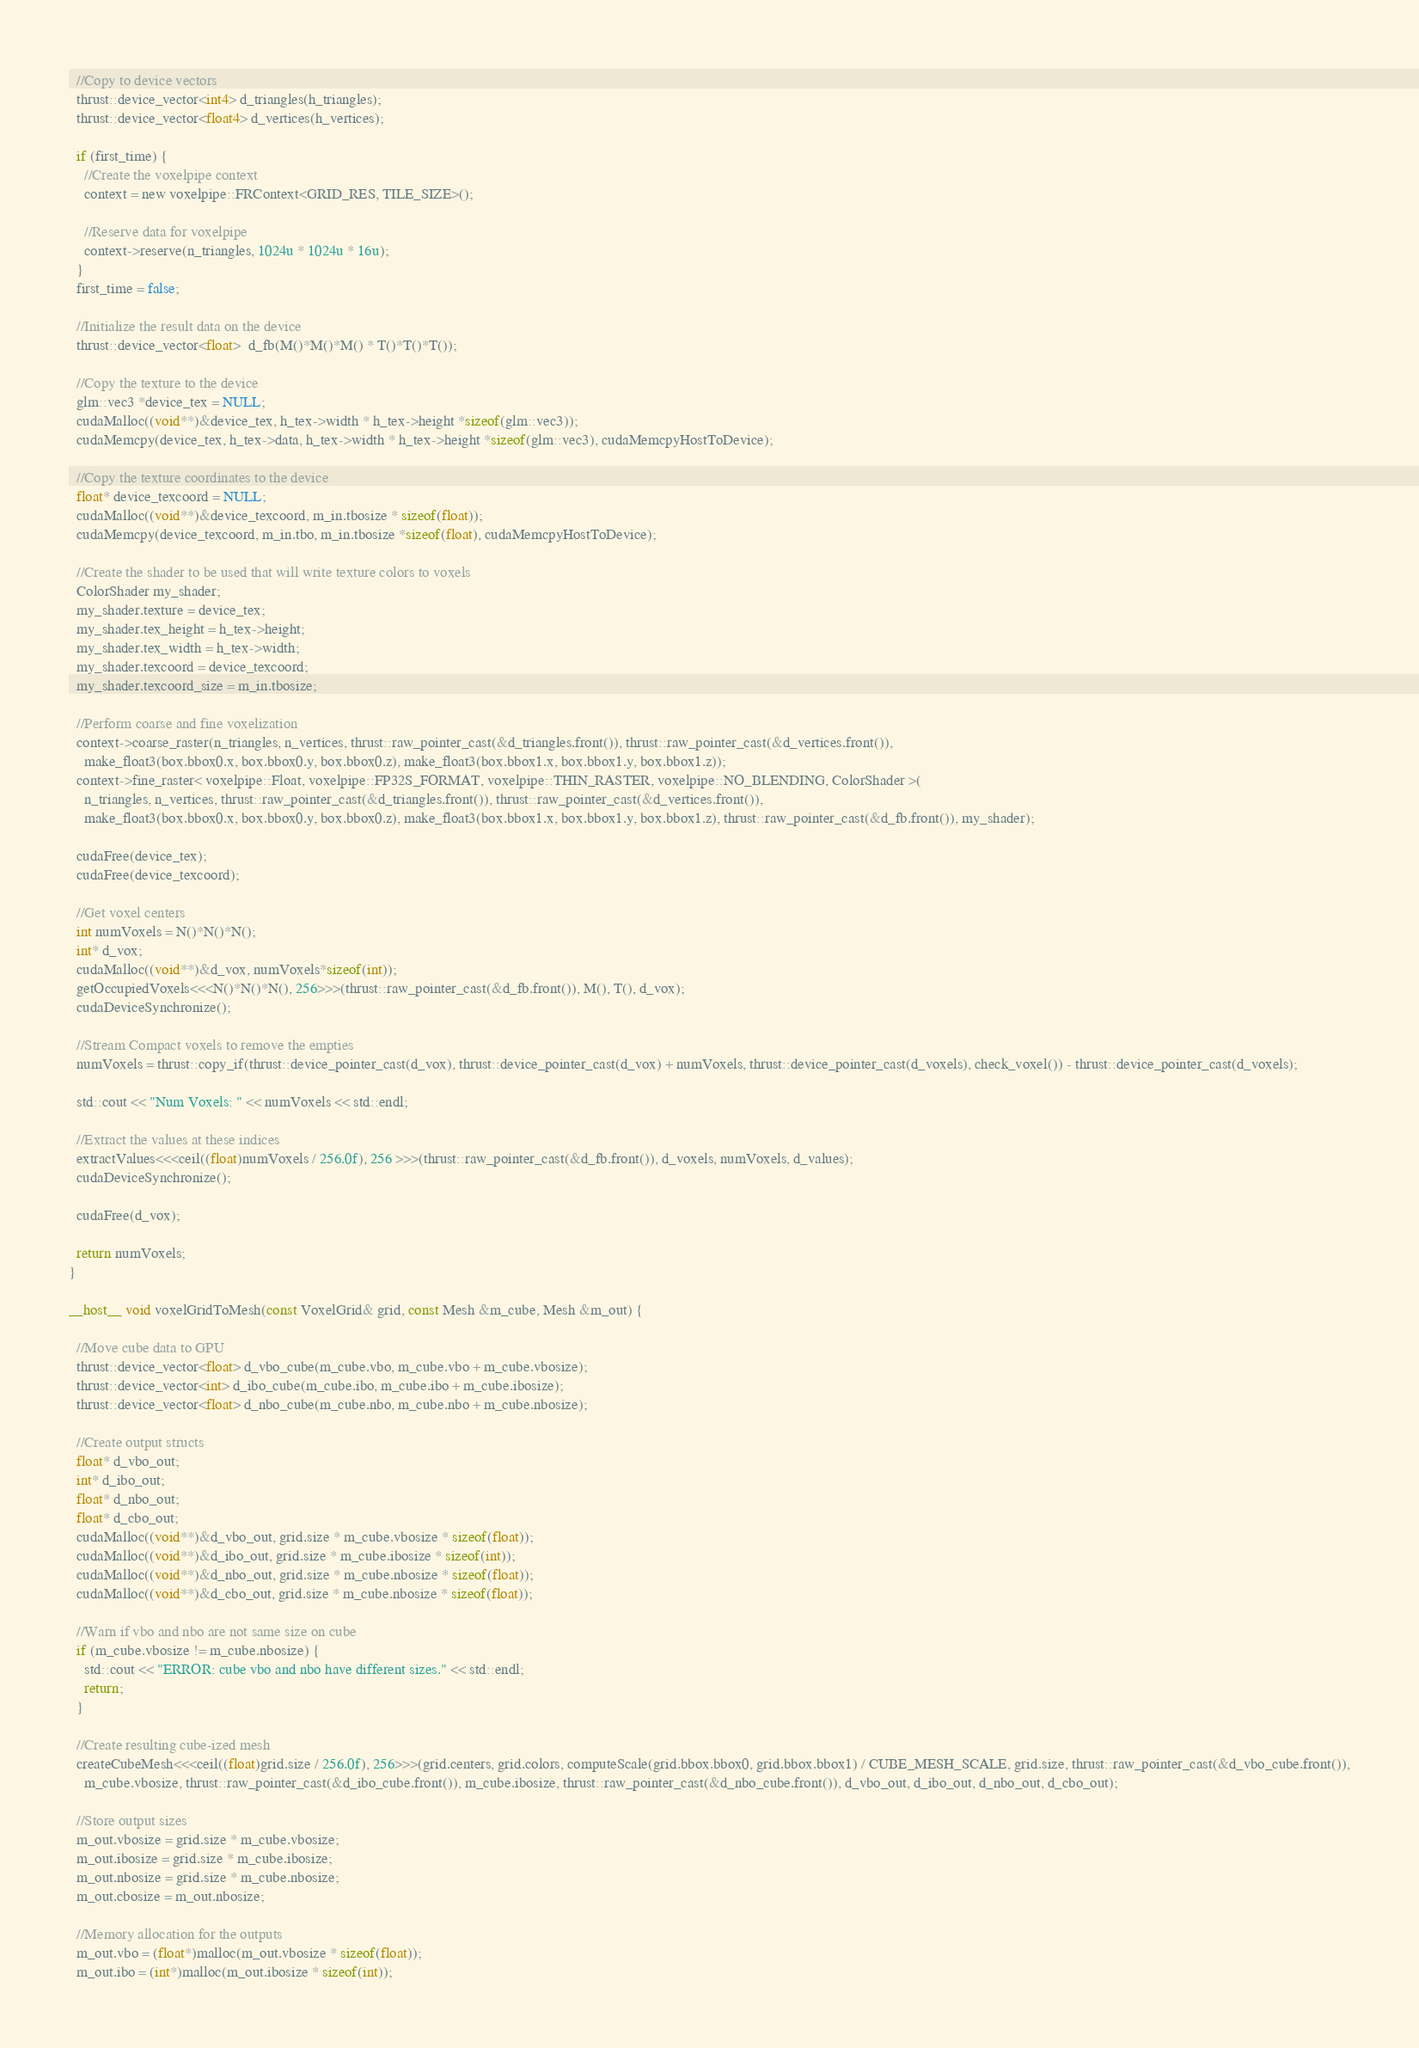Convert code to text. <code><loc_0><loc_0><loc_500><loc_500><_Cuda_>  //Copy to device vectors
  thrust::device_vector<int4> d_triangles(h_triangles);
  thrust::device_vector<float4> d_vertices(h_vertices);

  if (first_time) {
    //Create the voxelpipe context
    context = new voxelpipe::FRContext<GRID_RES, TILE_SIZE>();

    //Reserve data for voxelpipe
    context->reserve(n_triangles, 1024u * 1024u * 16u);
  }
  first_time = false;

  //Initialize the result data on the device
  thrust::device_vector<float>  d_fb(M()*M()*M() * T()*T()*T());

  //Copy the texture to the device
  glm::vec3 *device_tex = NULL;
  cudaMalloc((void**)&device_tex, h_tex->width * h_tex->height *sizeof(glm::vec3));
  cudaMemcpy(device_tex, h_tex->data, h_tex->width * h_tex->height *sizeof(glm::vec3), cudaMemcpyHostToDevice);

  //Copy the texture coordinates to the device
  float* device_texcoord = NULL;
  cudaMalloc((void**)&device_texcoord, m_in.tbosize * sizeof(float));
  cudaMemcpy(device_texcoord, m_in.tbo, m_in.tbosize *sizeof(float), cudaMemcpyHostToDevice);

  //Create the shader to be used that will write texture colors to voxels
  ColorShader my_shader;
  my_shader.texture = device_tex;
  my_shader.tex_height = h_tex->height;
  my_shader.tex_width = h_tex->width;
  my_shader.texcoord = device_texcoord;
  my_shader.texcoord_size = m_in.tbosize;

  //Perform coarse and fine voxelization
  context->coarse_raster(n_triangles, n_vertices, thrust::raw_pointer_cast(&d_triangles.front()), thrust::raw_pointer_cast(&d_vertices.front()), 
    make_float3(box.bbox0.x, box.bbox0.y, box.bbox0.z), make_float3(box.bbox1.x, box.bbox1.y, box.bbox1.z));
  context->fine_raster< voxelpipe::Float, voxelpipe::FP32S_FORMAT, voxelpipe::THIN_RASTER, voxelpipe::NO_BLENDING, ColorShader >(
    n_triangles, n_vertices, thrust::raw_pointer_cast(&d_triangles.front()), thrust::raw_pointer_cast(&d_vertices.front()), 
    make_float3(box.bbox0.x, box.bbox0.y, box.bbox0.z), make_float3(box.bbox1.x, box.bbox1.y, box.bbox1.z), thrust::raw_pointer_cast(&d_fb.front()), my_shader);

  cudaFree(device_tex);
  cudaFree(device_texcoord);

  //Get voxel centers
  int numVoxels = N()*N()*N();
  int* d_vox;
  cudaMalloc((void**)&d_vox, numVoxels*sizeof(int));
  getOccupiedVoxels<<<N()*N()*N(), 256>>>(thrust::raw_pointer_cast(&d_fb.front()), M(), T(), d_vox);
  cudaDeviceSynchronize();

  //Stream Compact voxels to remove the empties
  numVoxels = thrust::copy_if(thrust::device_pointer_cast(d_vox), thrust::device_pointer_cast(d_vox) + numVoxels, thrust::device_pointer_cast(d_voxels), check_voxel()) - thrust::device_pointer_cast(d_voxels);

  std::cout << "Num Voxels: " << numVoxels << std::endl;

  //Extract the values at these indices
  extractValues<<<ceil((float)numVoxels / 256.0f), 256 >>>(thrust::raw_pointer_cast(&d_fb.front()), d_voxels, numVoxels, d_values);
  cudaDeviceSynchronize();

  cudaFree(d_vox);

  return numVoxels;
}

__host__ void voxelGridToMesh(const VoxelGrid& grid, const Mesh &m_cube, Mesh &m_out) {

  //Move cube data to GPU
  thrust::device_vector<float> d_vbo_cube(m_cube.vbo, m_cube.vbo + m_cube.vbosize);
  thrust::device_vector<int> d_ibo_cube(m_cube.ibo, m_cube.ibo + m_cube.ibosize);
  thrust::device_vector<float> d_nbo_cube(m_cube.nbo, m_cube.nbo + m_cube.nbosize);

  //Create output structs
  float* d_vbo_out;
  int* d_ibo_out;
  float* d_nbo_out;
  float* d_cbo_out;
  cudaMalloc((void**)&d_vbo_out, grid.size * m_cube.vbosize * sizeof(float));
  cudaMalloc((void**)&d_ibo_out, grid.size * m_cube.ibosize * sizeof(int));
  cudaMalloc((void**)&d_nbo_out, grid.size * m_cube.nbosize * sizeof(float));
  cudaMalloc((void**)&d_cbo_out, grid.size * m_cube.nbosize * sizeof(float));

  //Warn if vbo and nbo are not same size on cube
  if (m_cube.vbosize != m_cube.nbosize) {
    std::cout << "ERROR: cube vbo and nbo have different sizes." << std::endl;
    return;
  }

  //Create resulting cube-ized mesh
  createCubeMesh<<<ceil((float)grid.size / 256.0f), 256>>>(grid.centers, grid.colors, computeScale(grid.bbox.bbox0, grid.bbox.bbox1) / CUBE_MESH_SCALE, grid.size, thrust::raw_pointer_cast(&d_vbo_cube.front()),
    m_cube.vbosize, thrust::raw_pointer_cast(&d_ibo_cube.front()), m_cube.ibosize, thrust::raw_pointer_cast(&d_nbo_cube.front()), d_vbo_out, d_ibo_out, d_nbo_out, d_cbo_out);

  //Store output sizes
  m_out.vbosize = grid.size * m_cube.vbosize;
  m_out.ibosize = grid.size * m_cube.ibosize;
  m_out.nbosize = grid.size * m_cube.nbosize;
  m_out.cbosize = m_out.nbosize;

  //Memory allocation for the outputs
  m_out.vbo = (float*)malloc(m_out.vbosize * sizeof(float));
  m_out.ibo = (int*)malloc(m_out.ibosize * sizeof(int));</code> 